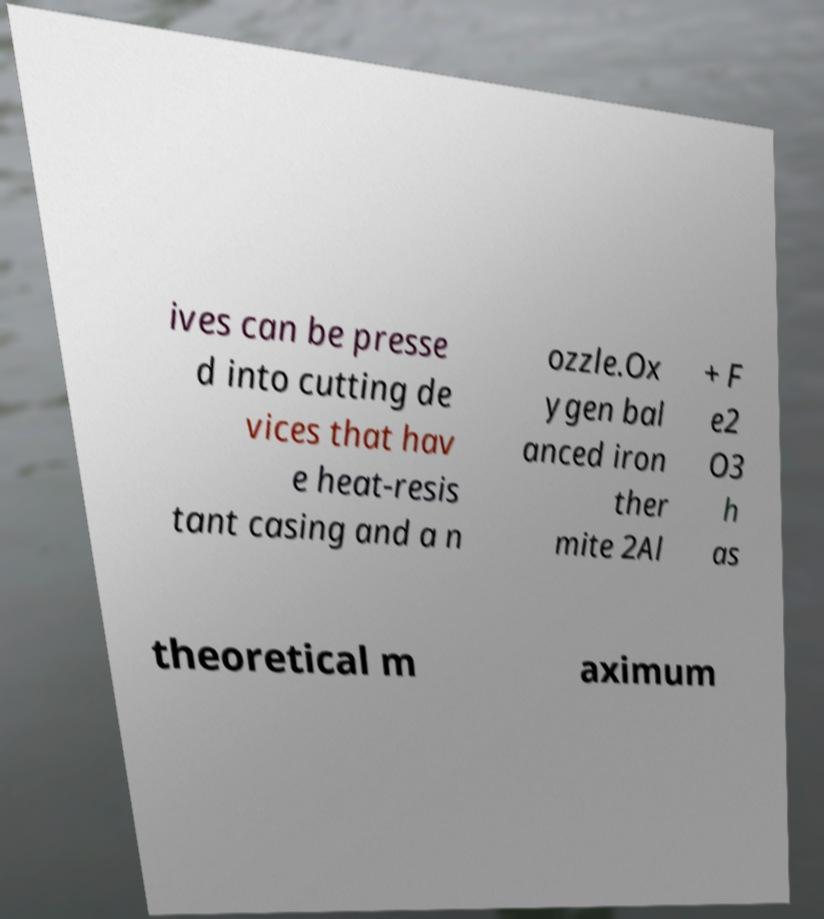There's text embedded in this image that I need extracted. Can you transcribe it verbatim? ives can be presse d into cutting de vices that hav e heat-resis tant casing and a n ozzle.Ox ygen bal anced iron ther mite 2Al + F e2 O3 h as theoretical m aximum 